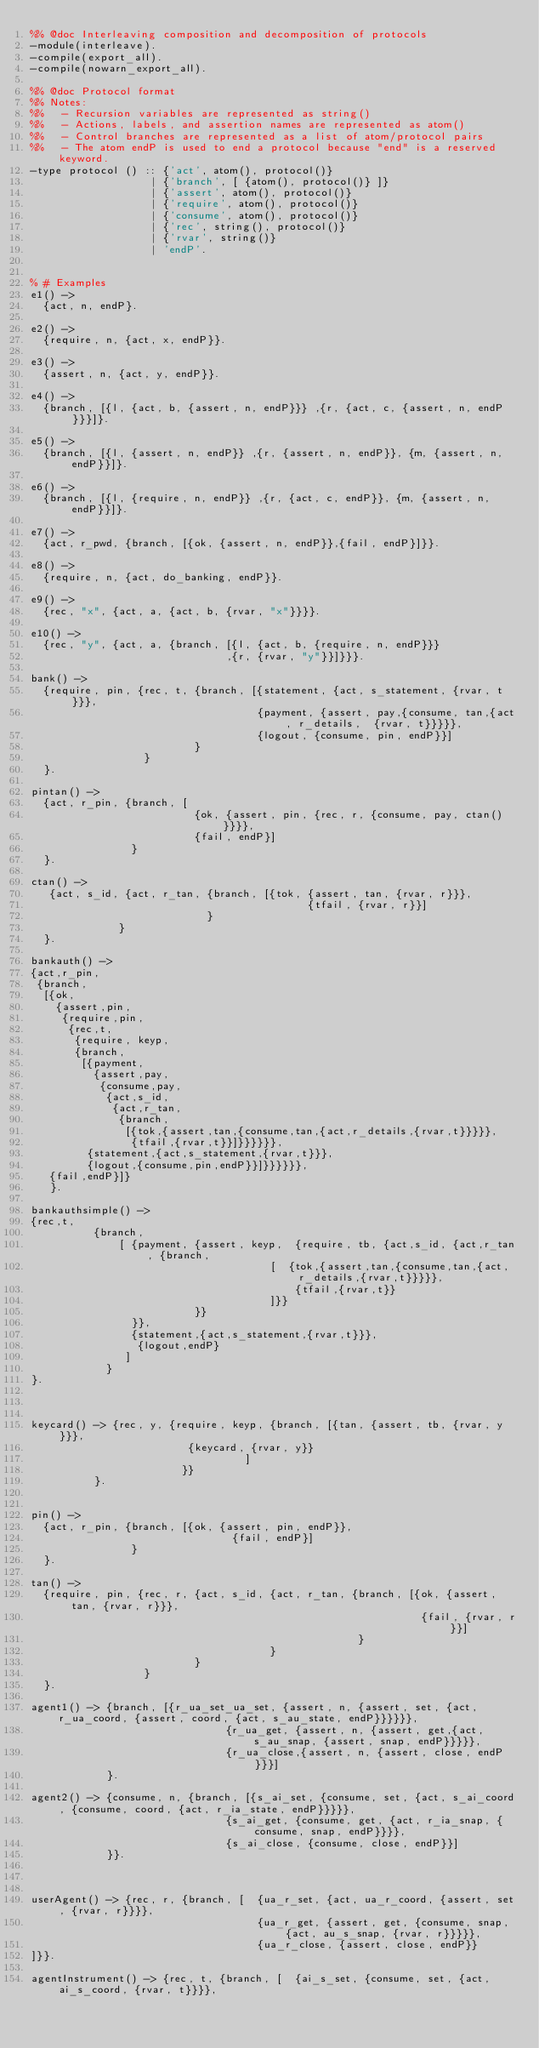<code> <loc_0><loc_0><loc_500><loc_500><_Erlang_>%% @doc Interleaving composition and decomposition of protocols
-module(interleave).
-compile(export_all).
-compile(nowarn_export_all).

%% @doc Protocol format
%% Notes:
%%   - Recursion variables are represented as string()
%%   - Actions, labels, and assertion names are represented as atom()
%%   - Control branches are represented as a list of atom/protocol pairs
%%   - The atom endP is used to end a protocol because "end" is a reserved keyword.
-type protocol () :: {'act', atom(), protocol()}
                   | {'branch', [ {atom(), protocol()} ]}
                   | {'assert', atom(), protocol()}
                   | {'require', atom(), protocol()}
                   | {'consume', atom(), protocol()}
                   | {'rec', string(), protocol()}
                   | {'rvar', string()}
                   | 'endP'.


% # Examples
e1() ->
  {act, n, endP}.

e2() ->
  {require, n, {act, x, endP}}.

e3() ->
  {assert, n, {act, y, endP}}.

e4() ->
  {branch, [{l, {act, b, {assert, n, endP}}} ,{r, {act, c, {assert, n, endP}}}]}.

e5() ->
  {branch, [{l, {assert, n, endP}} ,{r, {assert, n, endP}}, {m, {assert, n, endP}}]}.

e6() ->
  {branch, [{l, {require, n, endP}} ,{r, {act, c, endP}}, {m, {assert, n, endP}}]}.

e7() ->
  {act, r_pwd, {branch, [{ok, {assert, n, endP}},{fail, endP}]}}.

e8() ->
  {require, n, {act, do_banking, endP}}.

e9() ->
  {rec, "x", {act, a, {act, b, {rvar, "x"}}}}.

e10() ->
  {rec, "y", {act, a, {branch, [{l, {act, b, {require, n, endP}}}
                               ,{r, {rvar, "y"}}]}}}.

bank() ->
  {require, pin, {rec, t, {branch, [{statement, {act, s_statement, {rvar, t}}},
                                    {payment, {assert, pay,{consume, tan,{act, r_details,  {rvar, t}}}}},
                                    {logout, {consume, pin, endP}}]
                          }
                  }
  }.

pintan() ->
  {act, r_pin, {branch, [
                          {ok, {assert, pin, {rec, r, {consume, pay, ctan()}}}},
                          {fail, endP}]
                }
  }.

ctan() ->
   {act, s_id, {act, r_tan, {branch, [{tok, {assert, tan, {rvar, r}}},
                                            {tfail, {rvar, r}}]
                            }
              }
  }.

bankauth() ->
{act,r_pin,
 {branch,
  [{ok,
    {assert,pin,
     {require,pin,
      {rec,t,
       {require, keyp, 
       {branch,
        [{payment,
          {assert,pay,
           {consume,pay,
            {act,s_id,
             {act,r_tan,
              {branch,
               [{tok,{assert,tan,{consume,tan,{act,r_details,{rvar,t}}}}},
                {tfail,{rvar,t}}]}}}}}},
         {statement,{act,s_statement,{rvar,t}}},
         {logout,{consume,pin,endP}}]}}}}}},
   {fail,endP}]}
   }.
   
bankauthsimple() ->
{rec,t,
          {branch,
              [ {payment, {assert, keyp,  {require, tb, {act,s_id, {act,r_tan, {branch,
                                      [  {tok,{assert,tan,{consume,tan,{act,r_details,{rvar,t}}}}},
                                          {tfail,{rvar,t}}
                                      ]}}
                          }}
                }},
                {statement,{act,s_statement,{rvar,t}}},
                 {logout,endP}
               ]
            }
}.



keycard() -> {rec, y, {require, keyp, {branch, [{tan, {assert, tb, {rvar, y}}},
                         {keycard, {rvar, y}}
                                  ]
                        }}
          }.


pin() ->
  {act, r_pin, {branch, [{ok, {assert, pin, endP}},
                                {fail, endP}]
                }
  }.

tan() ->
  {require, pin, {rec, r, {act, s_id, {act, r_tan, {branch, [{ok, {assert, tan, {rvar, r}}},
                                                              {fail, {rvar, r}}]
                                                    }
                                      }
                          }
                  }
  }.

agent1() -> {branch, [{r_ua_set_ua_set, {assert, n, {assert, set, {act, r_ua_coord, {assert, coord, {act, s_au_state, endP}}}}}},
                               {r_ua_get, {assert, n, {assert, get,{act, s_au_snap, {assert, snap, endP}}}}},
                               {r_ua_close,{assert, n, {assert, close, endP}}}]
            }.

agent2() -> {consume, n, {branch, [{s_ai_set, {consume, set, {act, s_ai_coord, {consume, coord, {act, r_ia_state, endP}}}}},
                               {s_ai_get, {consume, get, {act, r_ia_snap, {consume, snap, endP}}}},
                               {s_ai_close, {consume, close, endP}}]
            }}.
            
            

userAgent() -> {rec, r, {branch, [  {ua_r_set, {act, ua_r_coord, {assert, set, {rvar, r}}}},
                                    {ua_r_get, {assert, get, {consume, snap, {act, au_s_snap, {rvar, r}}}}},
                                    {ua_r_close, {assert, close, endP}}
]}}.

agentInstrument() -> {rec, t, {branch, [  {ai_s_set, {consume, set, {act, ai_s_coord, {rvar, t}}}},</code> 